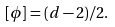Convert formula to latex. <formula><loc_0><loc_0><loc_500><loc_500>[ \phi ] = ( d - 2 ) / 2 .</formula> 